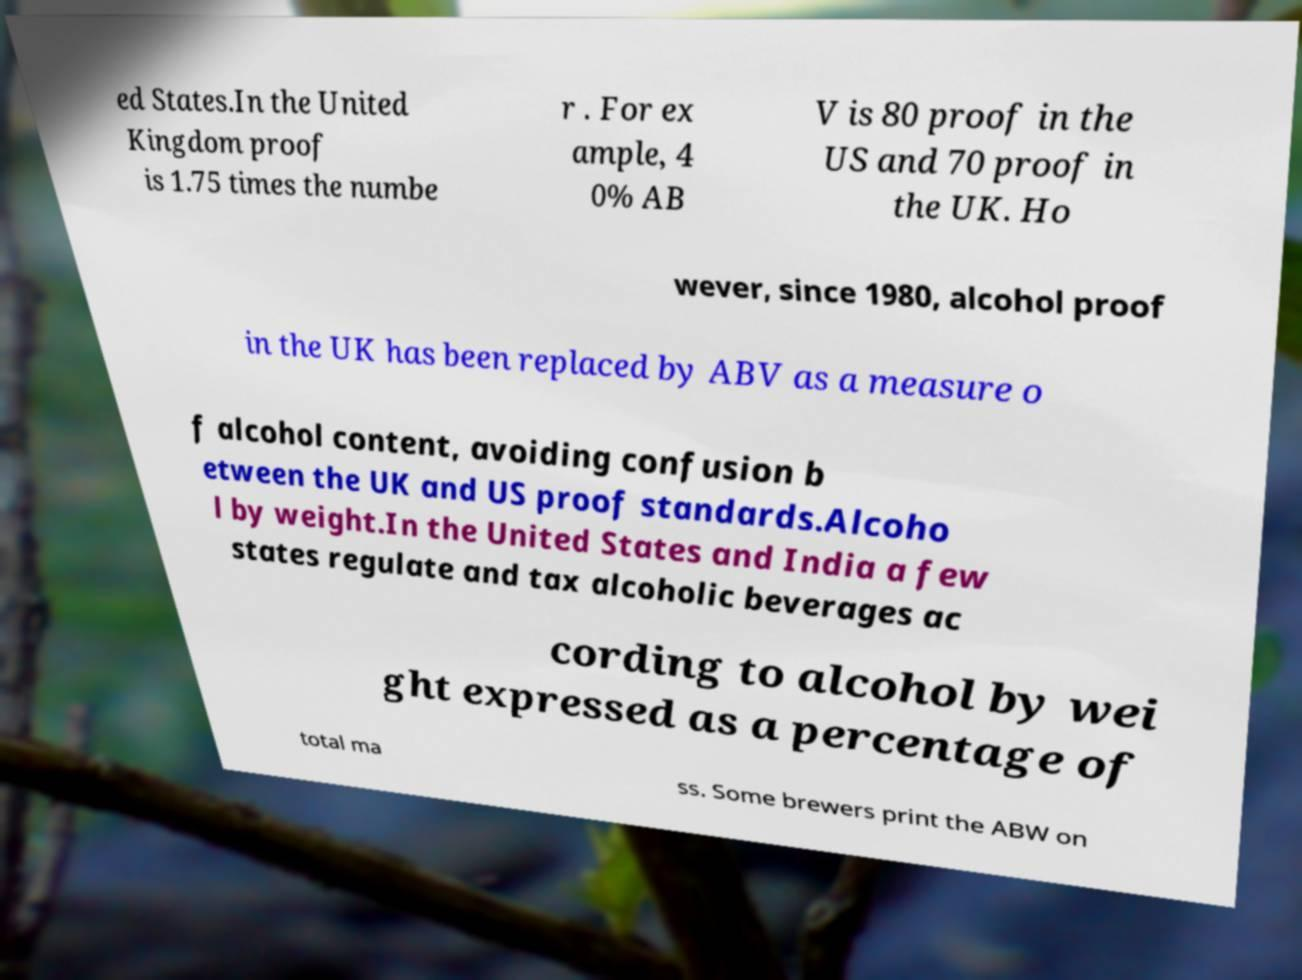I need the written content from this picture converted into text. Can you do that? ed States.In the United Kingdom proof is 1.75 times the numbe r . For ex ample, 4 0% AB V is 80 proof in the US and 70 proof in the UK. Ho wever, since 1980, alcohol proof in the UK has been replaced by ABV as a measure o f alcohol content, avoiding confusion b etween the UK and US proof standards.Alcoho l by weight.In the United States and India a few states regulate and tax alcoholic beverages ac cording to alcohol by wei ght expressed as a percentage of total ma ss. Some brewers print the ABW on 